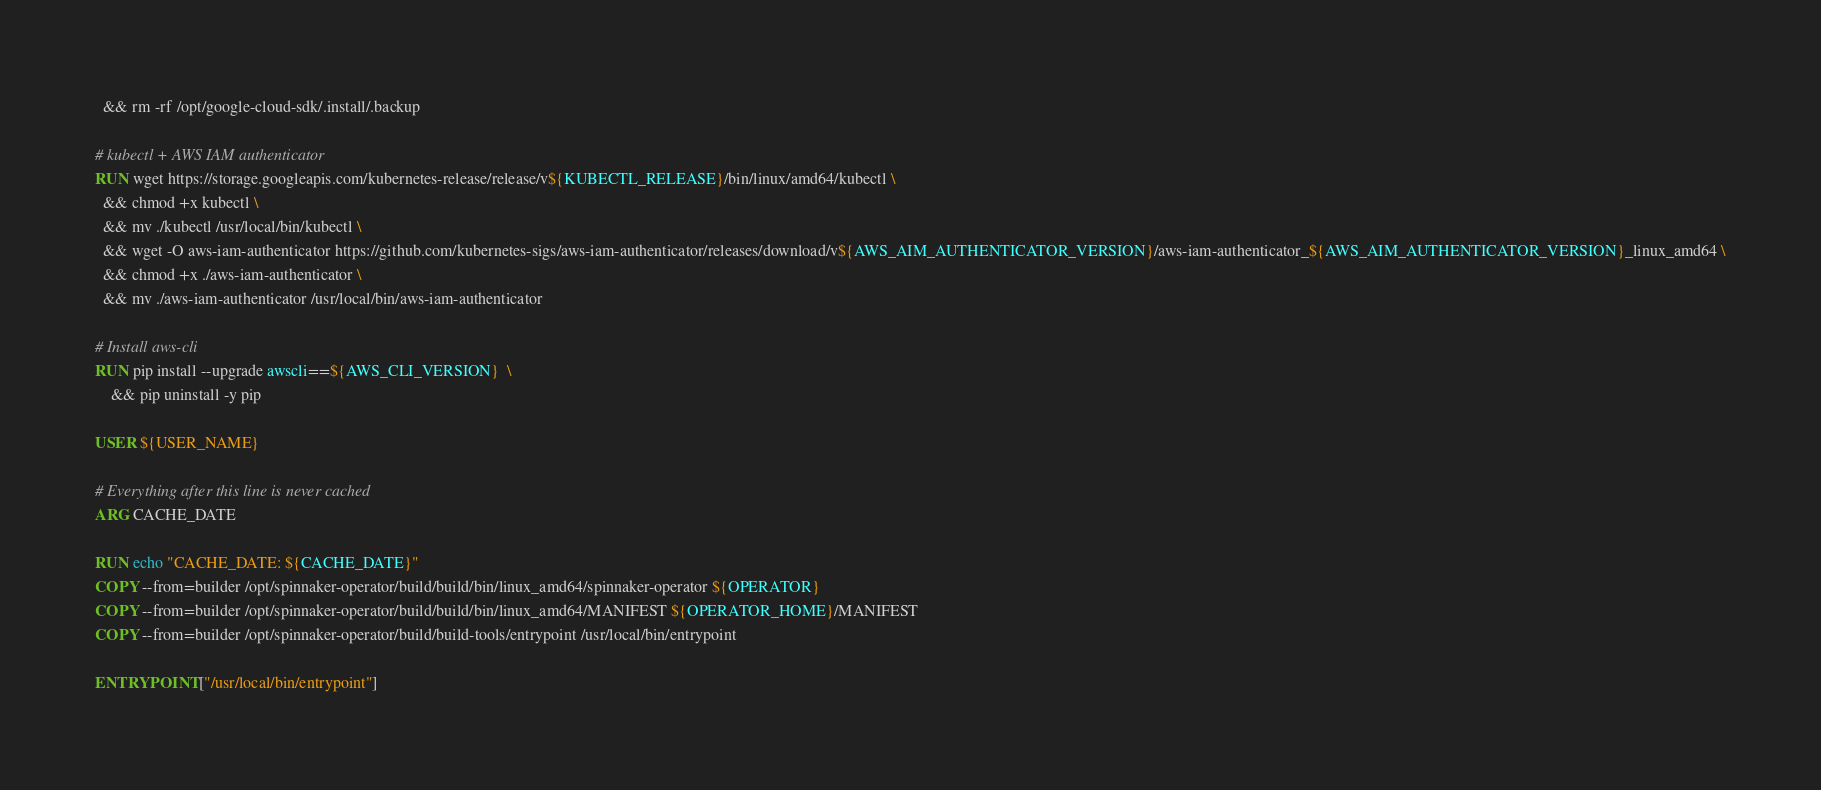<code> <loc_0><loc_0><loc_500><loc_500><_Dockerfile_>  && rm -rf /opt/google-cloud-sdk/.install/.backup

# kubectl + AWS IAM authenticator
RUN wget https://storage.googleapis.com/kubernetes-release/release/v${KUBECTL_RELEASE}/bin/linux/amd64/kubectl \
  && chmod +x kubectl \
  && mv ./kubectl /usr/local/bin/kubectl \
  && wget -O aws-iam-authenticator https://github.com/kubernetes-sigs/aws-iam-authenticator/releases/download/v${AWS_AIM_AUTHENTICATOR_VERSION}/aws-iam-authenticator_${AWS_AIM_AUTHENTICATOR_VERSION}_linux_amd64 \
  && chmod +x ./aws-iam-authenticator \
  && mv ./aws-iam-authenticator /usr/local/bin/aws-iam-authenticator

# Install aws-cli
RUN pip install --upgrade awscli==${AWS_CLI_VERSION}  \
    && pip uninstall -y pip

USER ${USER_NAME}

# Everything after this line is never cached
ARG CACHE_DATE

RUN echo "CACHE_DATE: ${CACHE_DATE}"
COPY --from=builder /opt/spinnaker-operator/build/build/bin/linux_amd64/spinnaker-operator ${OPERATOR}
COPY --from=builder /opt/spinnaker-operator/build/build/bin/linux_amd64/MANIFEST ${OPERATOR_HOME}/MANIFEST
COPY --from=builder /opt/spinnaker-operator/build/build-tools/entrypoint /usr/local/bin/entrypoint

ENTRYPOINT ["/usr/local/bin/entrypoint"]
</code> 